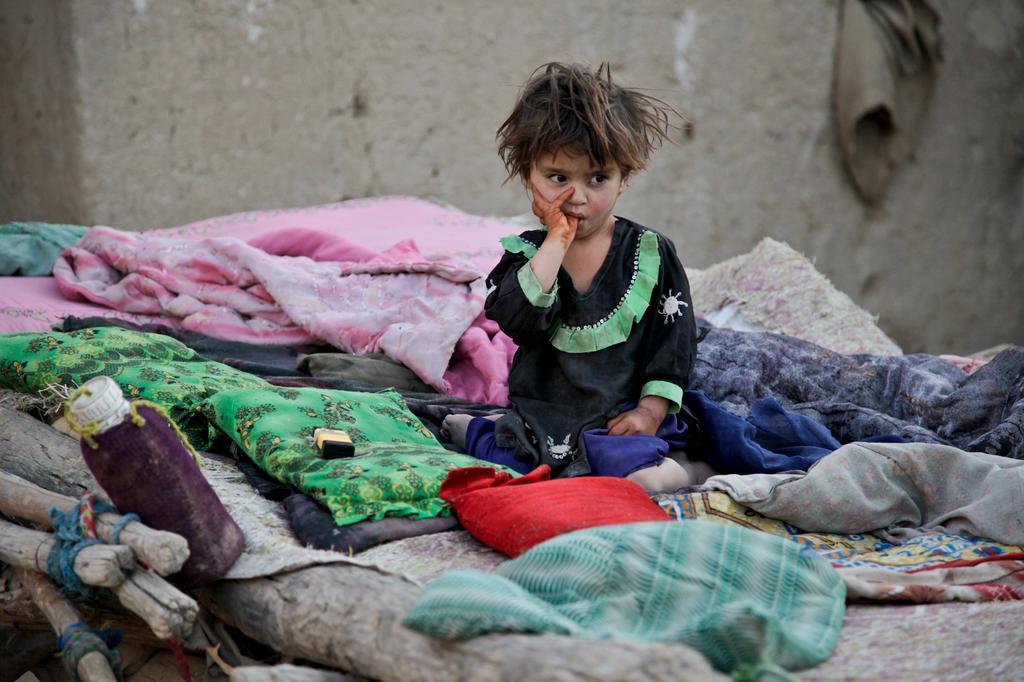How would you summarize this image in a sentence or two? In this image I can see a girl wearing black and green colored dress is sitting. I can see few clothes which are pink, green, blue in color and a red colored pillow around her. I can see a bottle , few wooden logs and in the background I can see the wall. 